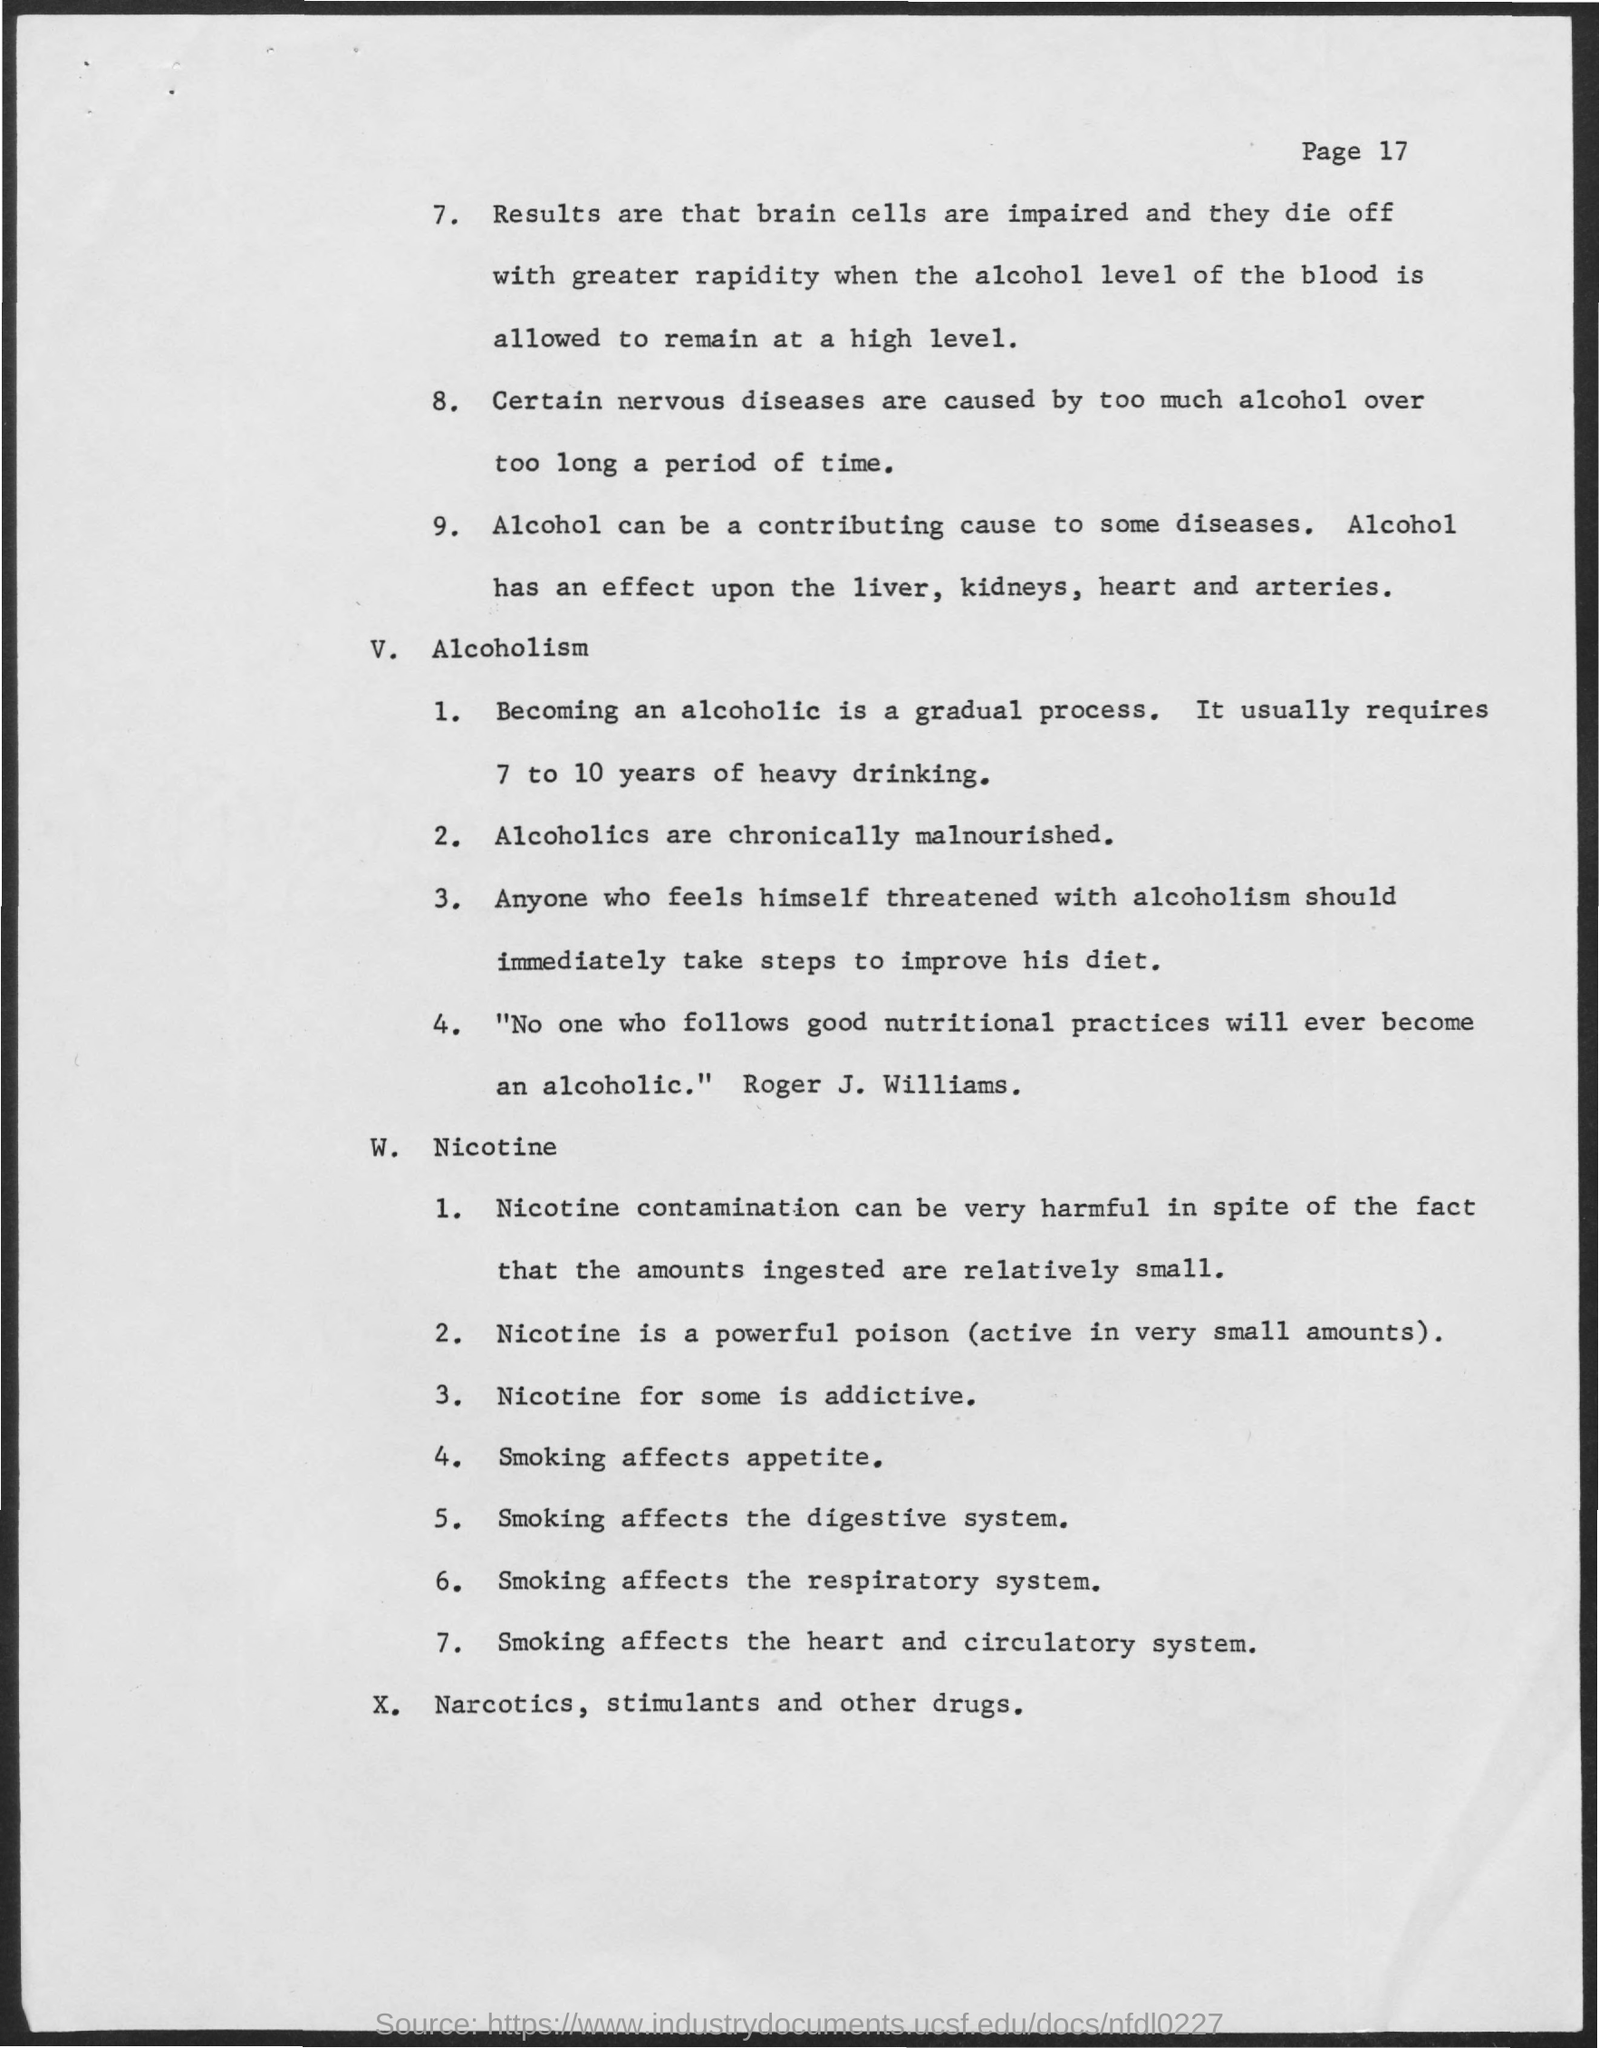What is the Page No?
Your response must be concise. 17. How long does it take to be an alcoholic?
Keep it short and to the point. 7 to 10 years of heavy drinking. 